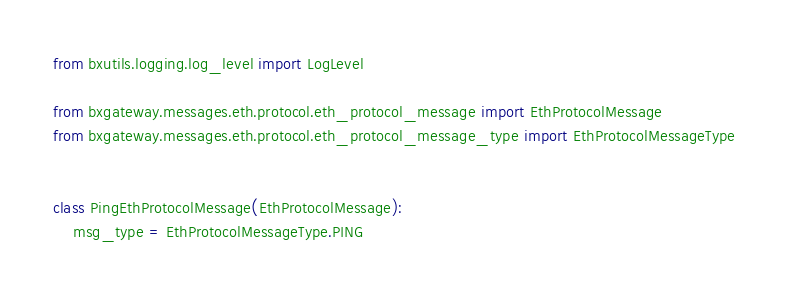Convert code to text. <code><loc_0><loc_0><loc_500><loc_500><_Python_>from bxutils.logging.log_level import LogLevel

from bxgateway.messages.eth.protocol.eth_protocol_message import EthProtocolMessage
from bxgateway.messages.eth.protocol.eth_protocol_message_type import EthProtocolMessageType


class PingEthProtocolMessage(EthProtocolMessage):
    msg_type = EthProtocolMessageType.PING
</code> 